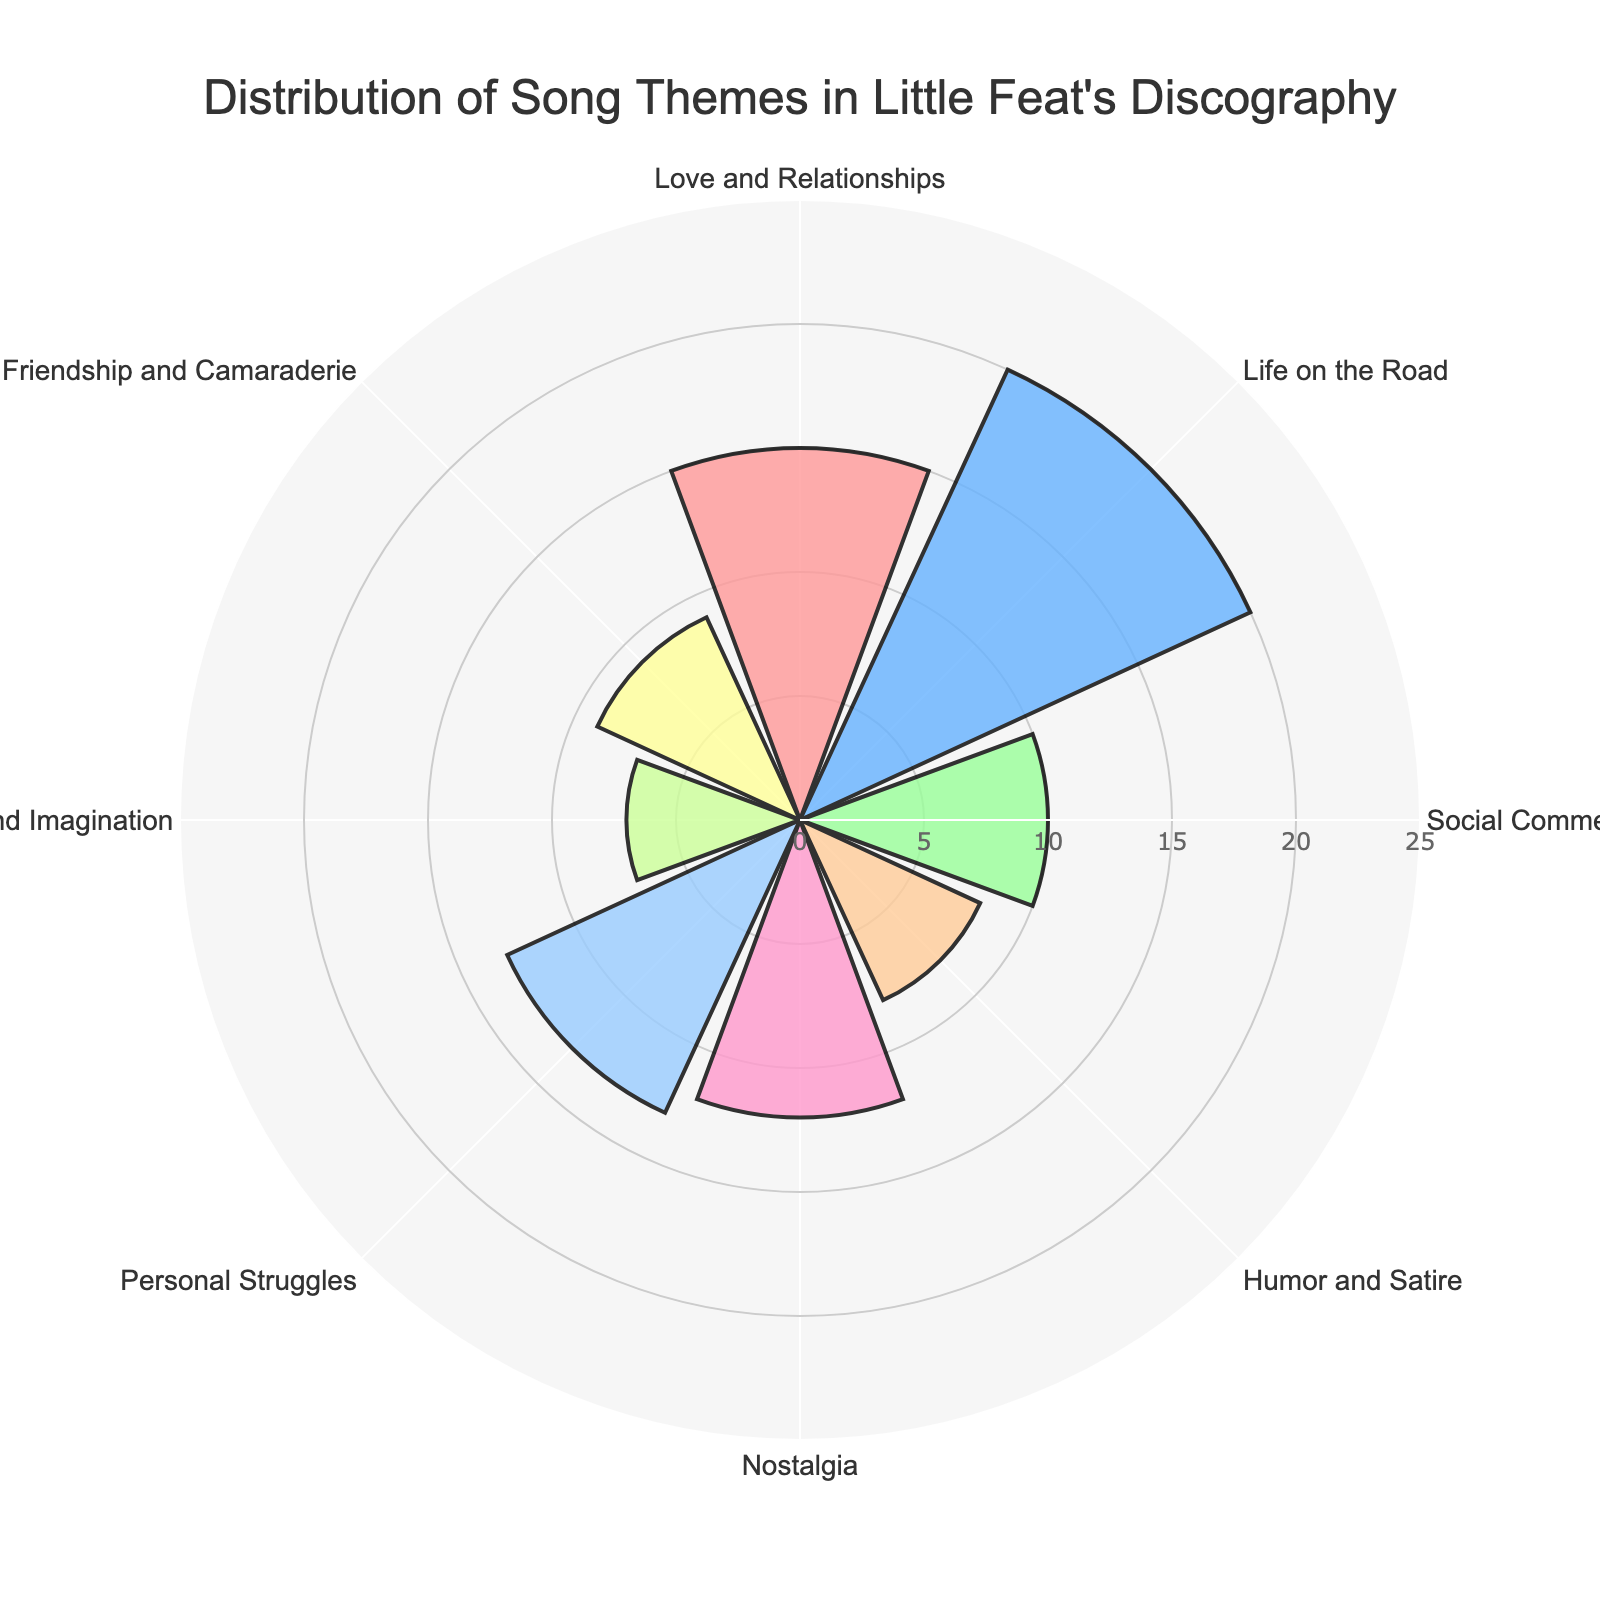what is the theme with the highest count of songs? By observing the heights of the bars, the theme "Life on the Road" has the highest value, indicating it covers 20 songs.
Answer: Life on the Road Which theme has the lowest count of songs? The shortest bar corresponds to the theme "Fantasy and Imagination," which has a count of 7 songs.
Answer: Fantasy and Imagination What is the total number of songs covered by the themes "Nostalgia" and "Personal Struggles"? The counts for "Nostalgia" and "Personal Struggles" are 12 and 13 respectively. Adding them gives 12 + 13 = 25.
Answer: 25 How many themes have a count greater than 10? By looking at the figure, the themes "Love and Relationships," "Life on the Road," "Nostalgia," and "Personal Struggles" each have counts exceeding 10. That makes 4 themes in total.
Answer: 4 Which themes have song counts close to each other within a difference of 1? "Friendship and Camaraderie" with 9 and "Humor and Satire" with 8 have counts with a difference of 9 - 8 = 1.
Answer: Friendship and Camaraderie, Humor and Satire What's the range of the song counts for all themes? The highest count is 20 for "Life on the Road" and the lowest is 7 for "Fantasy and Imagination." Subtracting these gives 20 - 7 = 13.
Answer: 13 What's the mean count of songs per theme? Sum all counts (15 + 20 + 10 + 8 + 12 + 13 + 7 + 9 = 94) and divide by the number of themes (8), giving 94/8 = 11.75.
Answer: 11.75 Which themes have exactly two fewer songs than the theme "Love and Relationships"? "Love and Relationships" has 15 songs. The themes with counts of 13 (which is 15 - 2) are "Personal Struggles."
Answer: Personal Struggles Does the theme "Humor and Satire" have more or fewer songs than "Friendship and Camaraderie"? Comparing the counts, "Humor and Satire" has 8, which is fewer than "Friendship and Camaraderie" with 9.
Answer: Fewer What percentage of the total songs is centered on "Life on the Road"? First calculate the total number of songs (94). Then find the proportion covered by the "Life on the Road" theme (20/94 * 100). This equals approx. 21.28%.
Answer: 21.28% 